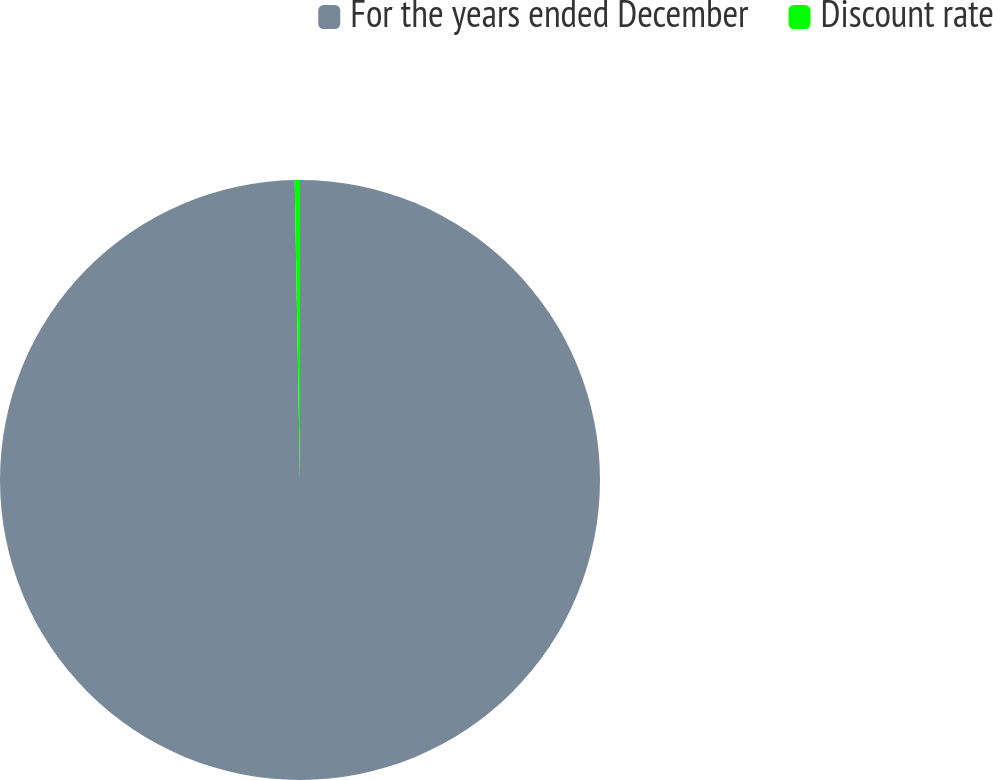<chart> <loc_0><loc_0><loc_500><loc_500><pie_chart><fcel>For the years ended December<fcel>Discount rate<nl><fcel>99.72%<fcel>0.28%<nl></chart> 